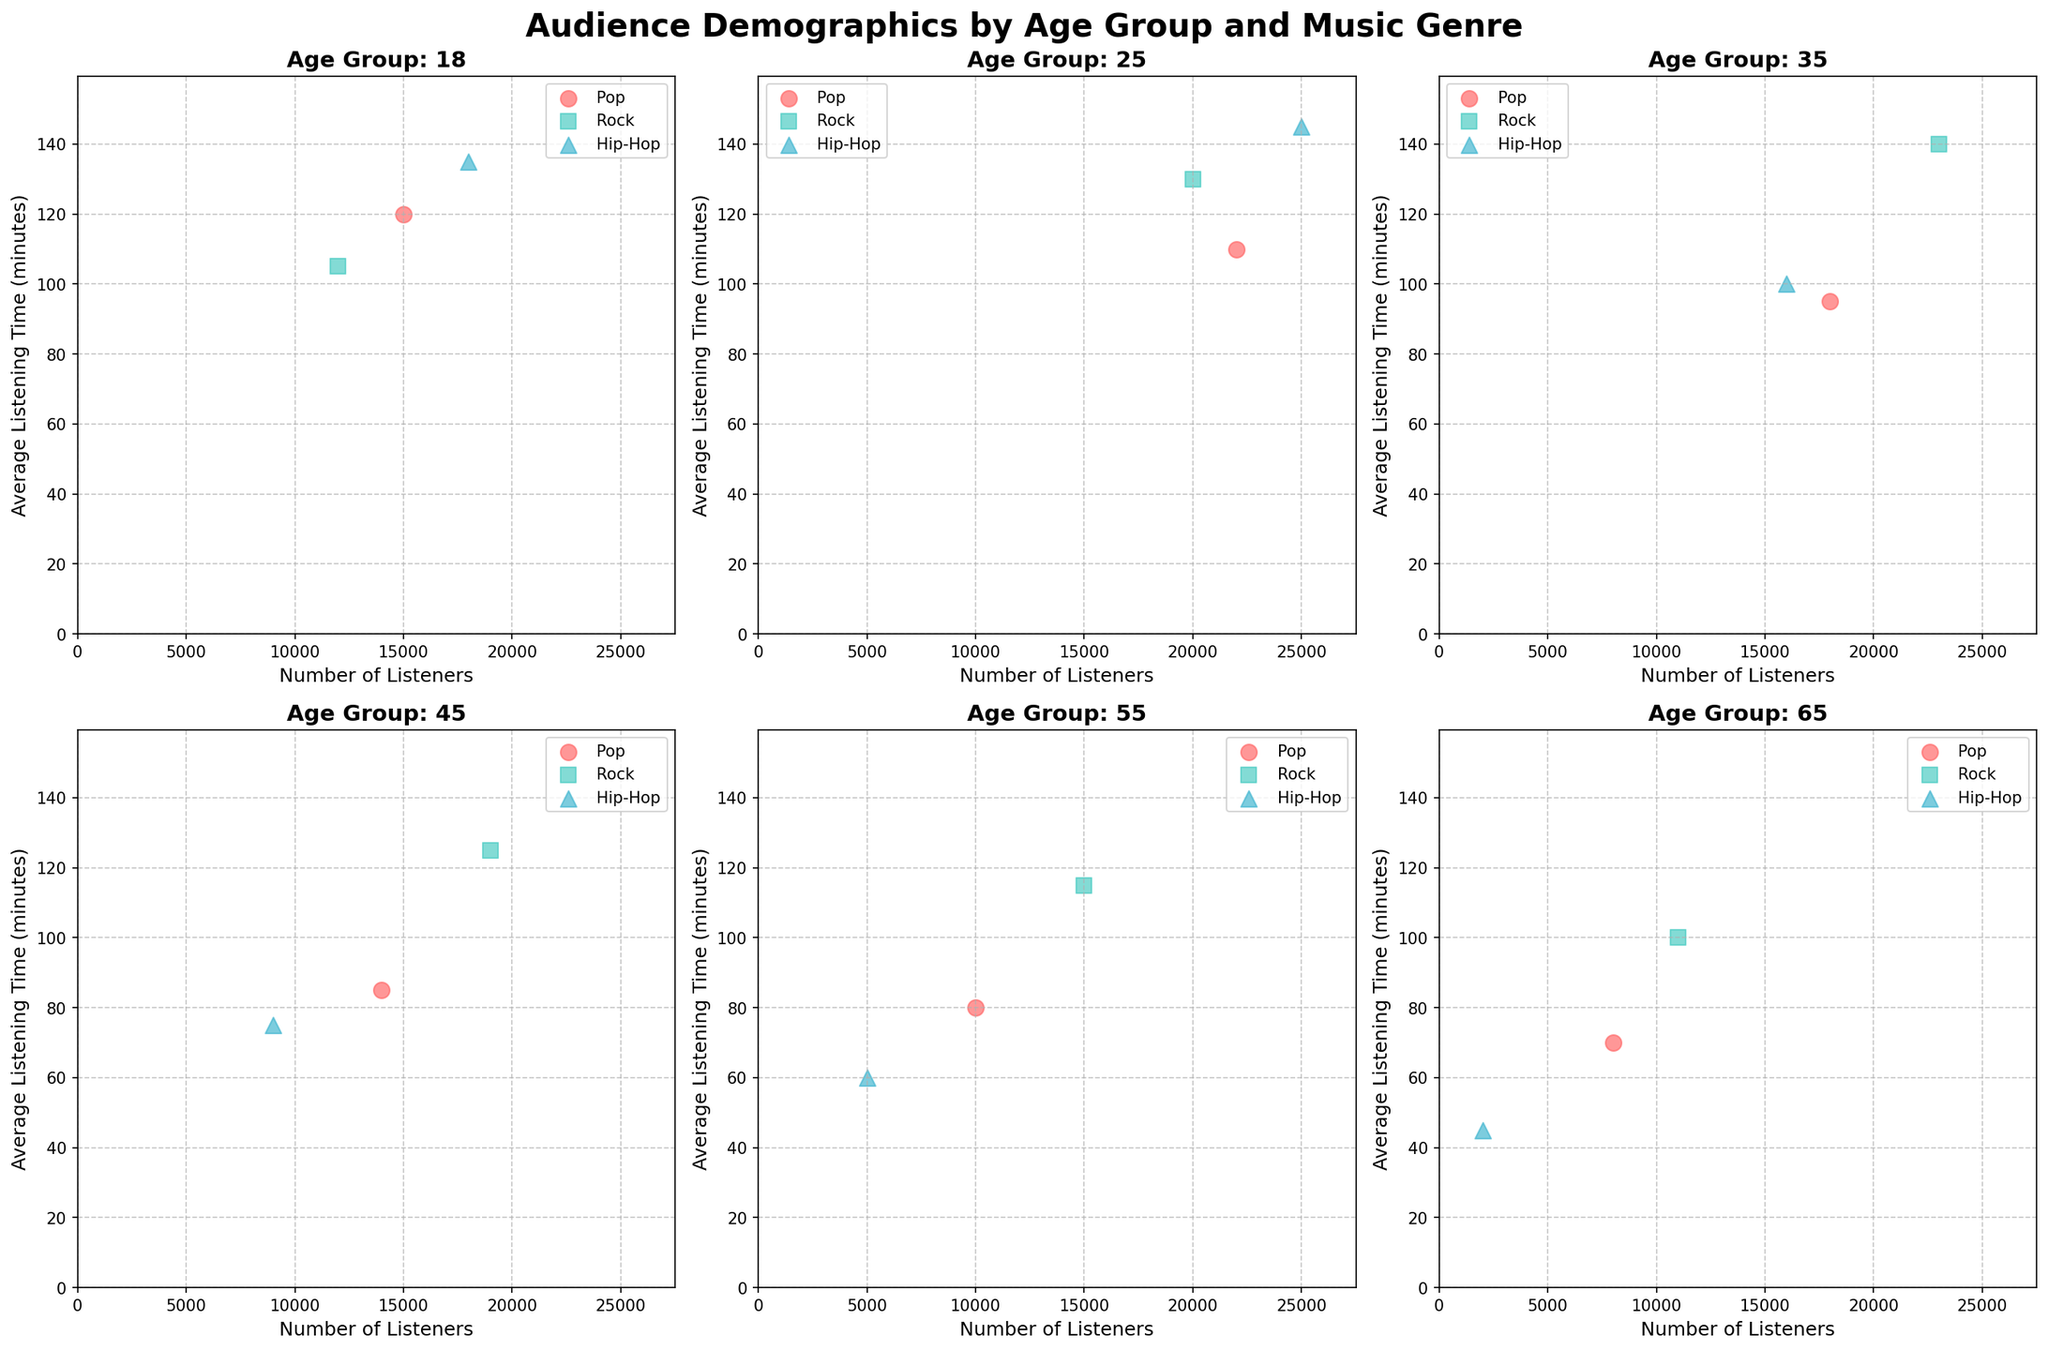Which age group has the highest number of listeners for Rock music? In the subplot for each age group, look at the x-axis value (Number of Listeners) for Rock music. Compare these values across all age groups. The highest value is 23000, which corresponds to the 35 age group.
Answer: Age group 35 What is the average listening time for Hip-Hop music in the 45 age group? For the 45 age group, locate the Hip-Hop data point and read the value on the y-axis (Average Listening Time). The value is 75 minutes.
Answer: 75 minutes Compare the number of listeners for Pop music between the 18 and 25 age groups. Who has more listeners? Find the data points for Pop music in the subplots for the 18 and 25 age groups and compare the x-axis values (Number of Listeners). The 25 age group has 22000 listeners, while the 18 age group has 15000 listeners.
Answer: 25 age group What is the range of average listening time for Rock music across all age groups? Identify the y-axis values (Average Listening Time) for Rock music in each age group's plot. The minimum value is 100 (65 age group) and the maximum value is 140 (35 age group). The range is 140 - 100 = 40 minutes.
Answer: 40 minutes How many age groups have a higher number of listeners for Hip-Hop than for Pop? For each age group, compare the number of listeners for Hip-Hop and Pop by looking at the x-axis values for these genres. The age groups 18 and 25 have more Hip-Hop listeners than Pop listeners.
Answer: 2 age groups Which genre has the most consistent average listening time across all age groups? Look at the spread of the y-axis values (Average Listening Time) for each genre across the subplots. Rock music has the most consistent values with a smaller range of 100 to 140 minutes compared to other genres.
Answer: Rock Is there any age group where the number of Pop listeners is less than 10000? Check the x-axis values (Number of Listeners) for Pop music in each subplot. No age group for Pop music has fewer than 10000 listeners, with the lowest being 8000 in the 65 age group.
Answer: No Which age group prefers Hip-Hop the most based on the number of listeners? For each age subplot, find the x-axis value (Number of Listeners) for Hip-Hop music and identify the highest value. The 25 age group has the most listeners with 25000.
Answer: Age group 25 